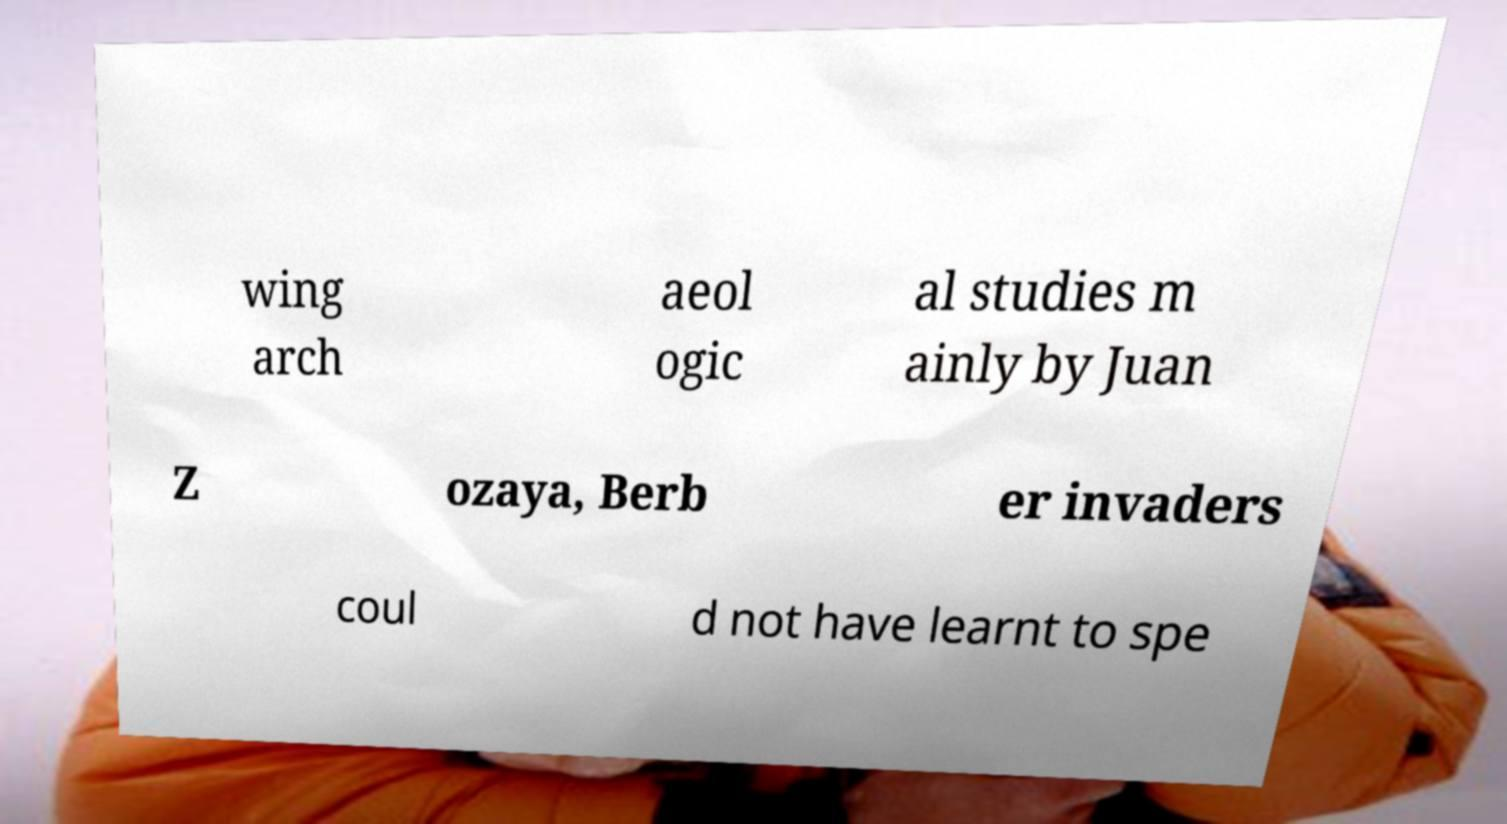Can you accurately transcribe the text from the provided image for me? wing arch aeol ogic al studies m ainly by Juan Z ozaya, Berb er invaders coul d not have learnt to spe 